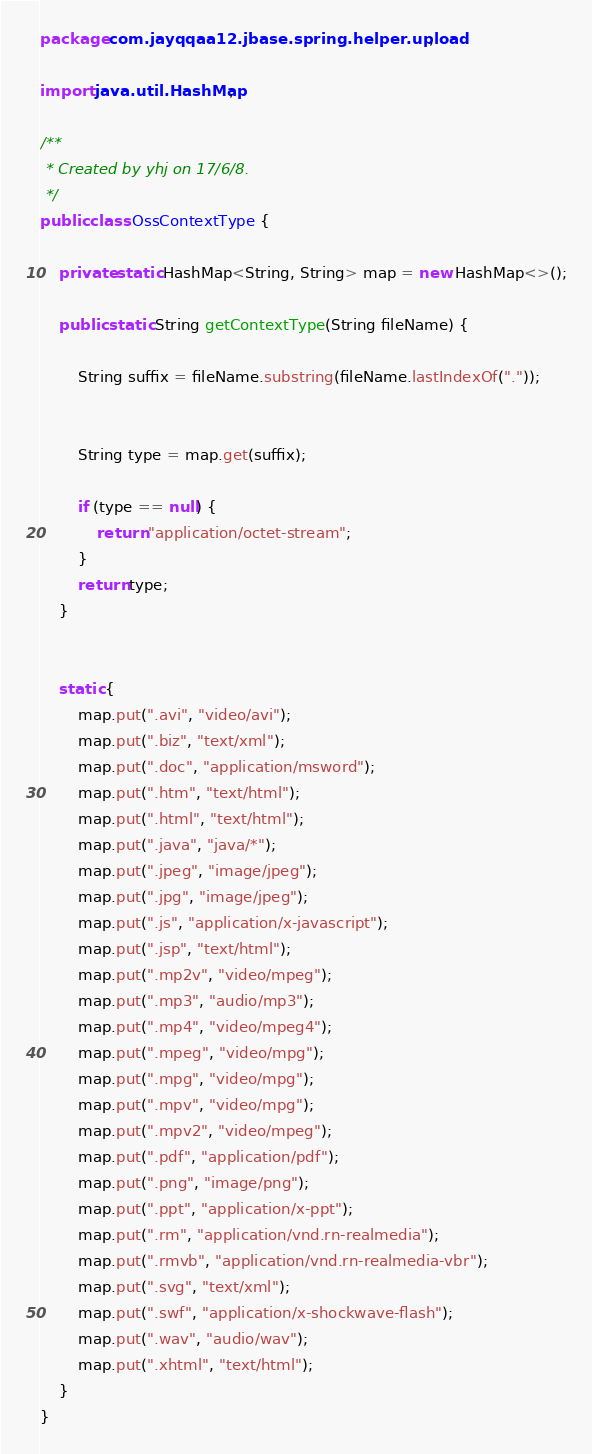<code> <loc_0><loc_0><loc_500><loc_500><_Java_>package com.jayqqaa12.jbase.spring.helper.upload;

import java.util.HashMap;

/**
 * Created by yhj on 17/6/8.
 */
public class OssContextType {

    private static HashMap<String, String> map = new HashMap<>();

    public static String getContextType(String fileName) {

        String suffix = fileName.substring(fileName.lastIndexOf("."));


        String type = map.get(suffix);

        if (type == null) {
            return "application/octet-stream";
        }
        return type;
    }


    static {
        map.put(".avi", "video/avi");
        map.put(".biz", "text/xml");
        map.put(".doc", "application/msword");
        map.put(".htm", "text/html");
        map.put(".html", "text/html");
        map.put(".java", "java/*");
        map.put(".jpeg", "image/jpeg");
        map.put(".jpg", "image/jpeg");
        map.put(".js", "application/x-javascript");
        map.put(".jsp", "text/html");
        map.put(".mp2v", "video/mpeg");
        map.put(".mp3", "audio/mp3");
        map.put(".mp4", "video/mpeg4");
        map.put(".mpeg", "video/mpg");
        map.put(".mpg", "video/mpg");
        map.put(".mpv", "video/mpg");
        map.put(".mpv2", "video/mpeg");
        map.put(".pdf", "application/pdf");
        map.put(".png", "image/png");
        map.put(".ppt", "application/x-ppt");
        map.put(".rm", "application/vnd.rn-realmedia");
        map.put(".rmvb", "application/vnd.rn-realmedia-vbr");
        map.put(".svg", "text/xml");
        map.put(".swf", "application/x-shockwave-flash");
        map.put(".wav", "audio/wav");
        map.put(".xhtml", "text/html");
    }
}
</code> 